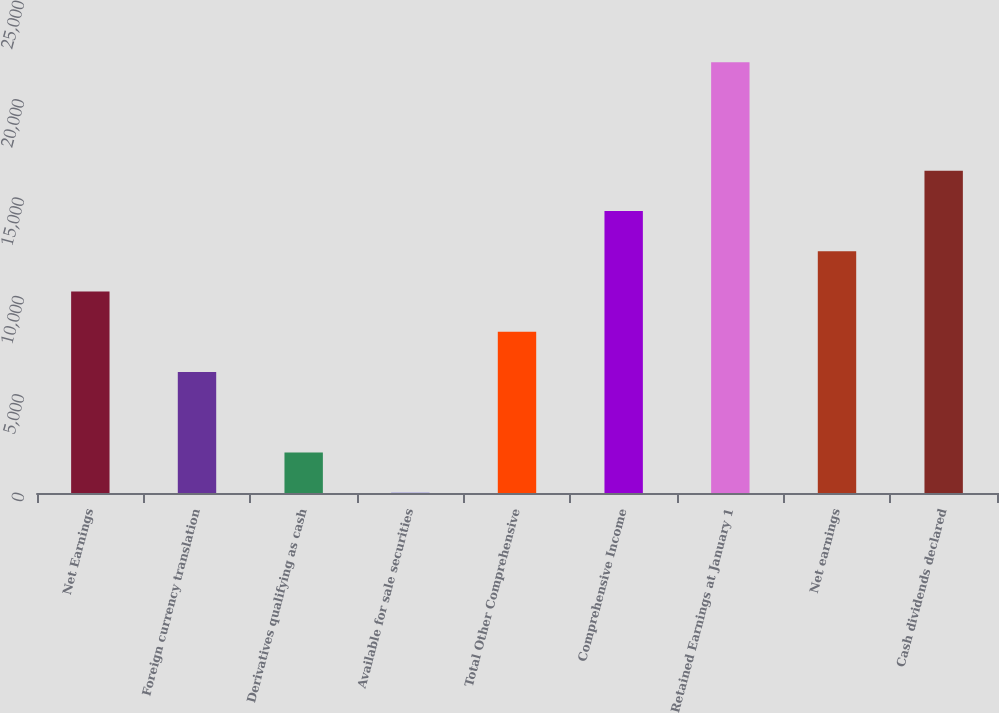<chart> <loc_0><loc_0><loc_500><loc_500><bar_chart><fcel>Net Earnings<fcel>Foreign currency translation<fcel>Derivatives qualifying as cash<fcel>Available for sale securities<fcel>Total Other Comprehensive<fcel>Comprehensive Income<fcel>Retained Earnings at January 1<fcel>Net earnings<fcel>Cash dividends declared<nl><fcel>10238<fcel>6147.6<fcel>2057.2<fcel>12<fcel>8192.8<fcel>14328.4<fcel>21890.2<fcel>12283.2<fcel>16373.6<nl></chart> 